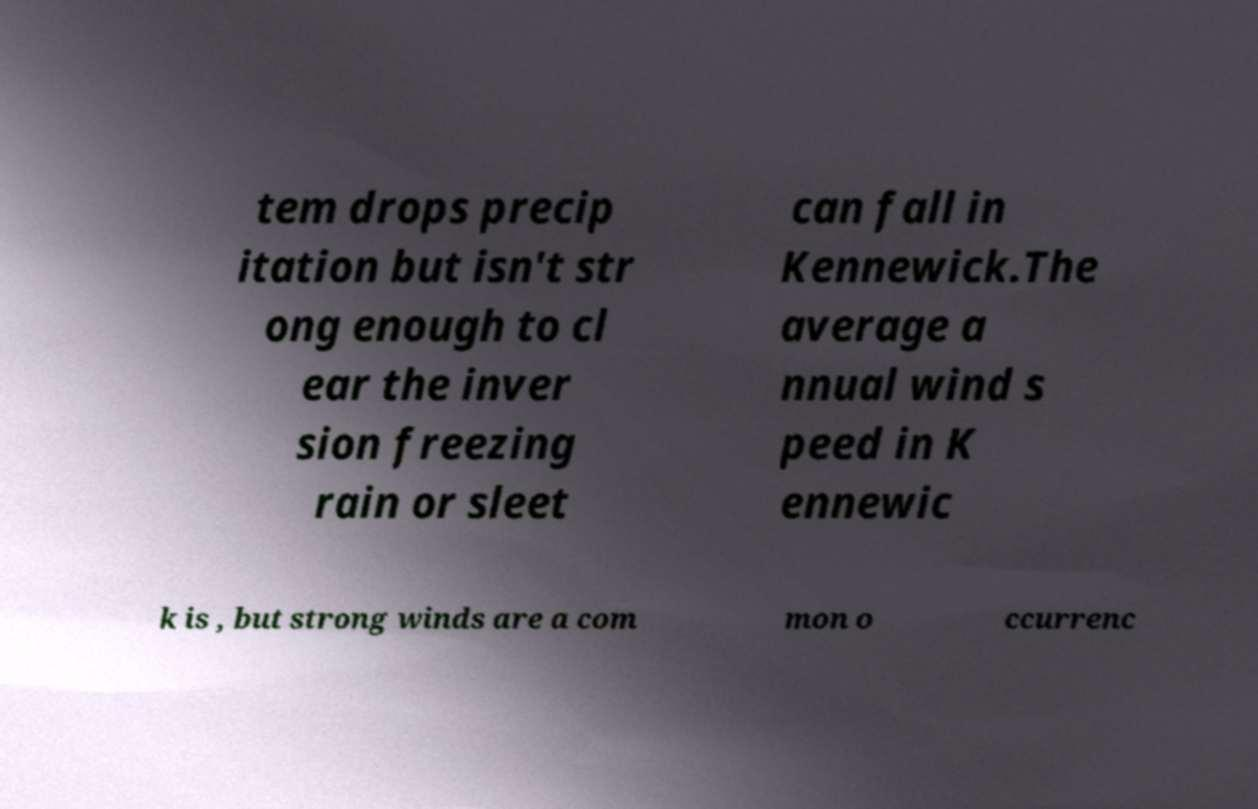I need the written content from this picture converted into text. Can you do that? tem drops precip itation but isn't str ong enough to cl ear the inver sion freezing rain or sleet can fall in Kennewick.The average a nnual wind s peed in K ennewic k is , but strong winds are a com mon o ccurrenc 